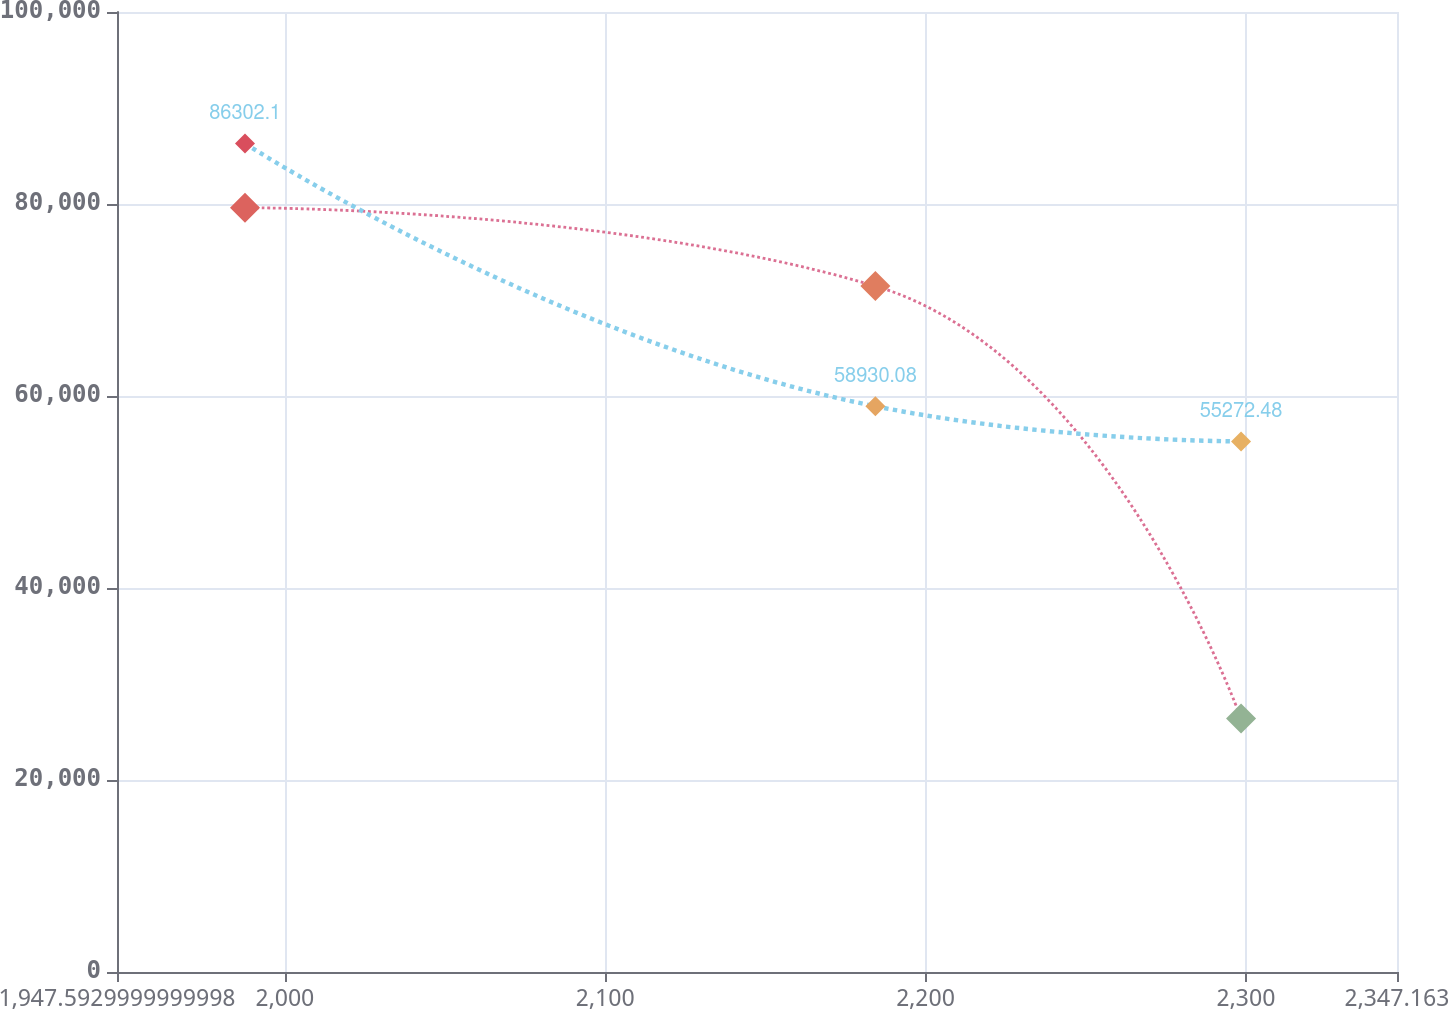<chart> <loc_0><loc_0><loc_500><loc_500><line_chart><ecel><fcel>Purchased Technology<fcel>Other Intangible Assets<nl><fcel>1987.55<fcel>79617<fcel>86302.1<nl><fcel>2184.34<fcel>71453.5<fcel>58930.1<nl><fcel>2298.48<fcel>26400.3<fcel>55272.5<nl><fcel>2349.81<fcel>18405.2<fcel>63238.3<nl><fcel>2387.12<fcel>9885.79<fcel>49726.1<nl></chart> 